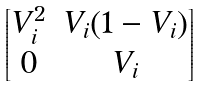Convert formula to latex. <formula><loc_0><loc_0><loc_500><loc_500>\begin{bmatrix} V _ { i } ^ { 2 } & V _ { i } ( 1 - V _ { i } ) \\ 0 & V _ { i } \end{bmatrix}</formula> 